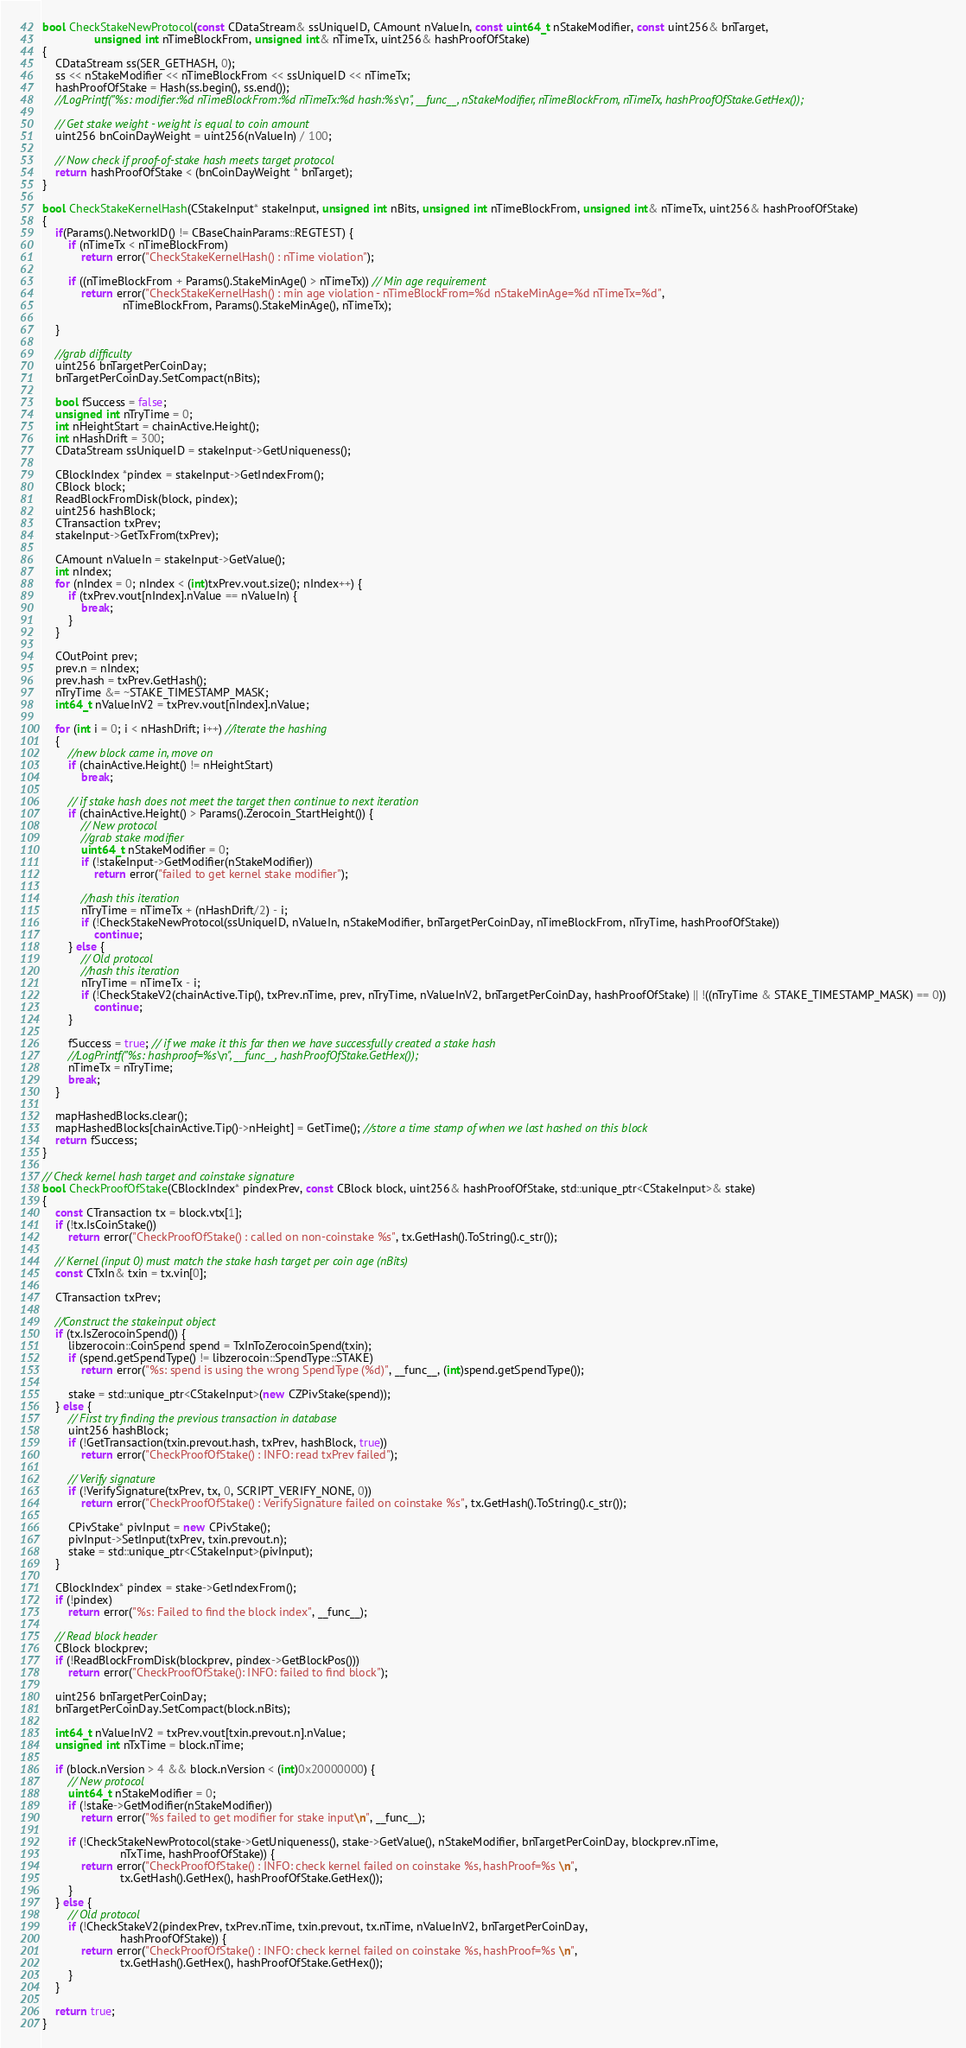Convert code to text. <code><loc_0><loc_0><loc_500><loc_500><_C++_>bool CheckStakeNewProtocol(const CDataStream& ssUniqueID, CAmount nValueIn, const uint64_t nStakeModifier, const uint256& bnTarget,
                unsigned int nTimeBlockFrom, unsigned int& nTimeTx, uint256& hashProofOfStake)
{
    CDataStream ss(SER_GETHASH, 0);
    ss << nStakeModifier << nTimeBlockFrom << ssUniqueID << nTimeTx;
    hashProofOfStake = Hash(ss.begin(), ss.end());
    //LogPrintf("%s: modifier:%d nTimeBlockFrom:%d nTimeTx:%d hash:%s\n", __func__, nStakeModifier, nTimeBlockFrom, nTimeTx, hashProofOfStake.GetHex());

    // Get stake weight - weight is equal to coin amount
    uint256 bnCoinDayWeight = uint256(nValueIn) / 100;

    // Now check if proof-of-stake hash meets target protocol
    return hashProofOfStake < (bnCoinDayWeight * bnTarget);
}

bool CheckStakeKernelHash(CStakeInput* stakeInput, unsigned int nBits, unsigned int nTimeBlockFrom, unsigned int& nTimeTx, uint256& hashProofOfStake)
{
    if(Params().NetworkID() != CBaseChainParams::REGTEST) {
        if (nTimeTx < nTimeBlockFrom)
            return error("CheckStakeKernelHash() : nTime violation");

        if ((nTimeBlockFrom + Params().StakeMinAge() > nTimeTx)) // Min age requirement
            return error("CheckStakeKernelHash() : min age violation - nTimeBlockFrom=%d nStakeMinAge=%d nTimeTx=%d",
                         nTimeBlockFrom, Params().StakeMinAge(), nTimeTx);

    }

    //grab difficulty
    uint256 bnTargetPerCoinDay;
    bnTargetPerCoinDay.SetCompact(nBits);

    bool fSuccess = false;
    unsigned int nTryTime = 0;
    int nHeightStart = chainActive.Height();
    int nHashDrift = 300;
    CDataStream ssUniqueID = stakeInput->GetUniqueness();

    CBlockIndex *pindex = stakeInput->GetIndexFrom();
    CBlock block;
    ReadBlockFromDisk(block, pindex);
    uint256 hashBlock;
    CTransaction txPrev;
    stakeInput->GetTxFrom(txPrev);

    CAmount nValueIn = stakeInput->GetValue();
    int nIndex;
    for (nIndex = 0; nIndex < (int)txPrev.vout.size(); nIndex++) {
        if (txPrev.vout[nIndex].nValue == nValueIn) {
            break;
        }
    }

    COutPoint prev;
    prev.n = nIndex;
    prev.hash = txPrev.GetHash();
    nTryTime &= ~STAKE_TIMESTAMP_MASK;
    int64_t nValueInV2 = txPrev.vout[nIndex].nValue;

    for (int i = 0; i < nHashDrift; i++) //iterate the hashing
    {
        //new block came in, move on
        if (chainActive.Height() != nHeightStart)
            break;

        // if stake hash does not meet the target then continue to next iteration
        if (chainActive.Height() > Params().Zerocoin_StartHeight()) {
            // New protocol
            //grab stake modifier
            uint64_t nStakeModifier = 0;
            if (!stakeInput->GetModifier(nStakeModifier))
                return error("failed to get kernel stake modifier");

            //hash this iteration
            nTryTime = nTimeTx + (nHashDrift/2) - i;
            if (!CheckStakeNewProtocol(ssUniqueID, nValueIn, nStakeModifier, bnTargetPerCoinDay, nTimeBlockFrom, nTryTime, hashProofOfStake))
                continue;
        } else {
            // Old protocol
            //hash this iteration
            nTryTime = nTimeTx - i;
            if (!CheckStakeV2(chainActive.Tip(), txPrev.nTime, prev, nTryTime, nValueInV2, bnTargetPerCoinDay, hashProofOfStake) || !((nTryTime & STAKE_TIMESTAMP_MASK) == 0))
                continue;
        }

        fSuccess = true; // if we make it this far then we have successfully created a stake hash
        //LogPrintf("%s: hashproof=%s\n", __func__, hashProofOfStake.GetHex());
        nTimeTx = nTryTime;
        break;
    }

    mapHashedBlocks.clear();
    mapHashedBlocks[chainActive.Tip()->nHeight] = GetTime(); //store a time stamp of when we last hashed on this block
    return fSuccess;
}

// Check kernel hash target and coinstake signature
bool CheckProofOfStake(CBlockIndex* pindexPrev, const CBlock block, uint256& hashProofOfStake, std::unique_ptr<CStakeInput>& stake)
{
    const CTransaction tx = block.vtx[1];
    if (!tx.IsCoinStake())
        return error("CheckProofOfStake() : called on non-coinstake %s", tx.GetHash().ToString().c_str());

    // Kernel (input 0) must match the stake hash target per coin age (nBits)
    const CTxIn& txin = tx.vin[0];

    CTransaction txPrev;

    //Construct the stakeinput object
    if (tx.IsZerocoinSpend()) {
        libzerocoin::CoinSpend spend = TxInToZerocoinSpend(txin);
        if (spend.getSpendType() != libzerocoin::SpendType::STAKE)
            return error("%s: spend is using the wrong SpendType (%d)", __func__, (int)spend.getSpendType());

        stake = std::unique_ptr<CStakeInput>(new CZPivStake(spend));
    } else {
        // First try finding the previous transaction in database
        uint256 hashBlock;
        if (!GetTransaction(txin.prevout.hash, txPrev, hashBlock, true))
            return error("CheckProofOfStake() : INFO: read txPrev failed");

        // Verify signature
        if (!VerifySignature(txPrev, tx, 0, SCRIPT_VERIFY_NONE, 0))
            return error("CheckProofOfStake() : VerifySignature failed on coinstake %s", tx.GetHash().ToString().c_str());

        CPivStake* pivInput = new CPivStake();
        pivInput->SetInput(txPrev, txin.prevout.n);
        stake = std::unique_ptr<CStakeInput>(pivInput);
    }

    CBlockIndex* pindex = stake->GetIndexFrom();
    if (!pindex)
        return error("%s: Failed to find the block index", __func__);

    // Read block header
    CBlock blockprev;
    if (!ReadBlockFromDisk(blockprev, pindex->GetBlockPos()))
        return error("CheckProofOfStake(): INFO: failed to find block");

    uint256 bnTargetPerCoinDay;
    bnTargetPerCoinDay.SetCompact(block.nBits);

    int64_t nValueInV2 = txPrev.vout[txin.prevout.n].nValue;
    unsigned int nTxTime = block.nTime;

    if (block.nVersion > 4 && block.nVersion < (int)0x20000000) {
        // New protocol
        uint64_t nStakeModifier = 0;
        if (!stake->GetModifier(nStakeModifier))
            return error("%s failed to get modifier for stake input\n", __func__);

        if (!CheckStakeNewProtocol(stake->GetUniqueness(), stake->GetValue(), nStakeModifier, bnTargetPerCoinDay, blockprev.nTime,
                        nTxTime, hashProofOfStake)) {
            return error("CheckProofOfStake() : INFO: check kernel failed on coinstake %s, hashProof=%s \n",
                        tx.GetHash().GetHex(), hashProofOfStake.GetHex());
        }
    } else {
        // Old protocol
        if (!CheckStakeV2(pindexPrev, txPrev.nTime, txin.prevout, tx.nTime, nValueInV2, bnTargetPerCoinDay,
                        hashProofOfStake)) {
            return error("CheckProofOfStake() : INFO: check kernel failed on coinstake %s, hashProof=%s \n",
                        tx.GetHash().GetHex(), hashProofOfStake.GetHex());
        }
    }

    return true;
}
</code> 